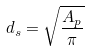<formula> <loc_0><loc_0><loc_500><loc_500>d _ { s } = \sqrt { \frac { A _ { p } } { \pi } }</formula> 